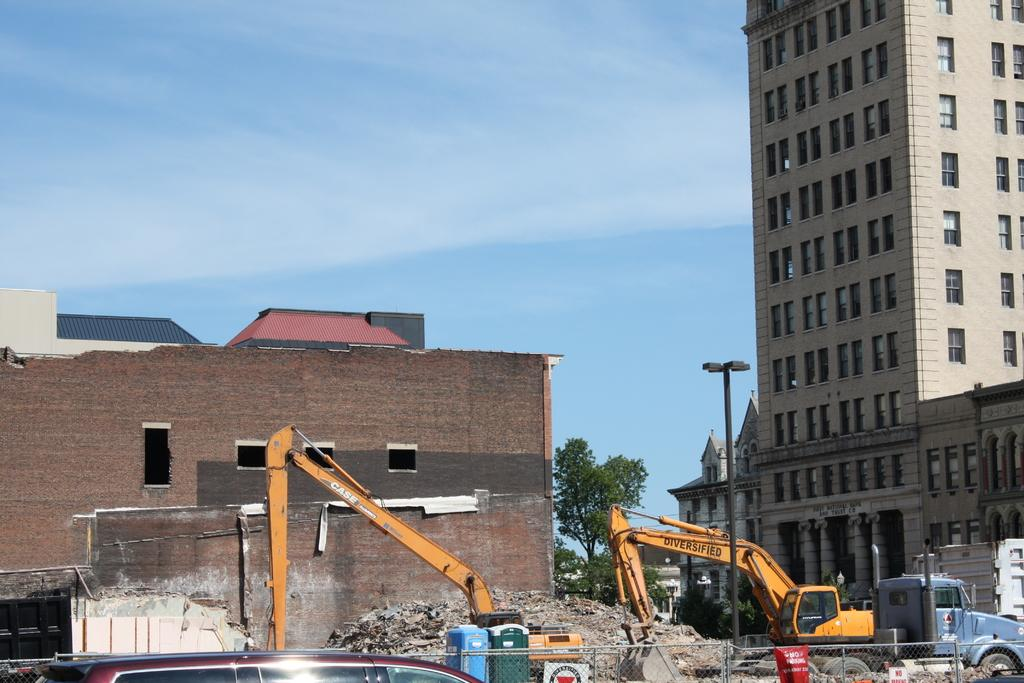What type of machinery can be seen in the image? There are cranes in the image. What else can be seen on the path in the image? There are vehicles on the path in the image. What is used to separate the path from other areas in the image? There is fencing on the path in the image. What is provided for waste disposal in the image? There are dustbins in the image. What can be seen in the distance in the image? There are buildings and trees in the background of the image. What type of arch can be seen in the image? There is no arch present in the image. What type of pleasure can be seen in the image? The image does not depict any pleasure or leisure activities; it primarily shows machinery, vehicles, and infrastructure. 